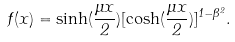Convert formula to latex. <formula><loc_0><loc_0><loc_500><loc_500>f ( x ) = \sinh ( \frac { \mu x } { 2 } ) [ \cosh ( \frac { \mu x } { 2 } ) ] ^ { 1 - \beta ^ { 2 } } .</formula> 